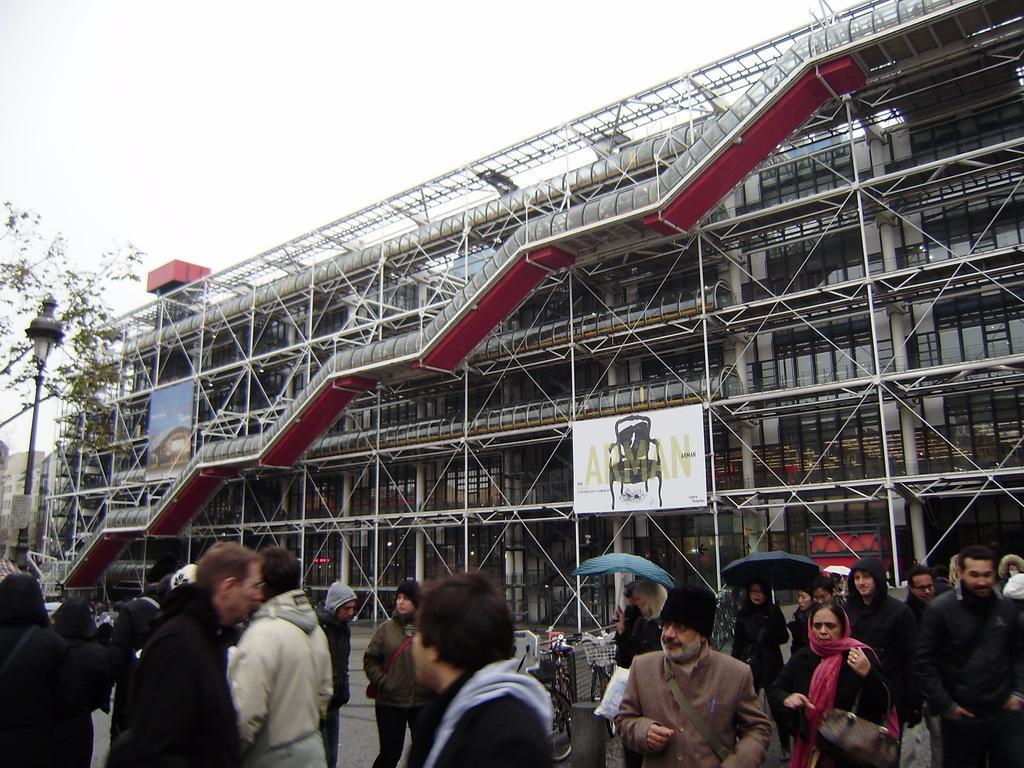Can you describe this image briefly? In this picture I can see group of people walking on the road, there are umbrellas, vehicles, boards, tree, light, pole, a building, stairs , and in the background there is sky. 